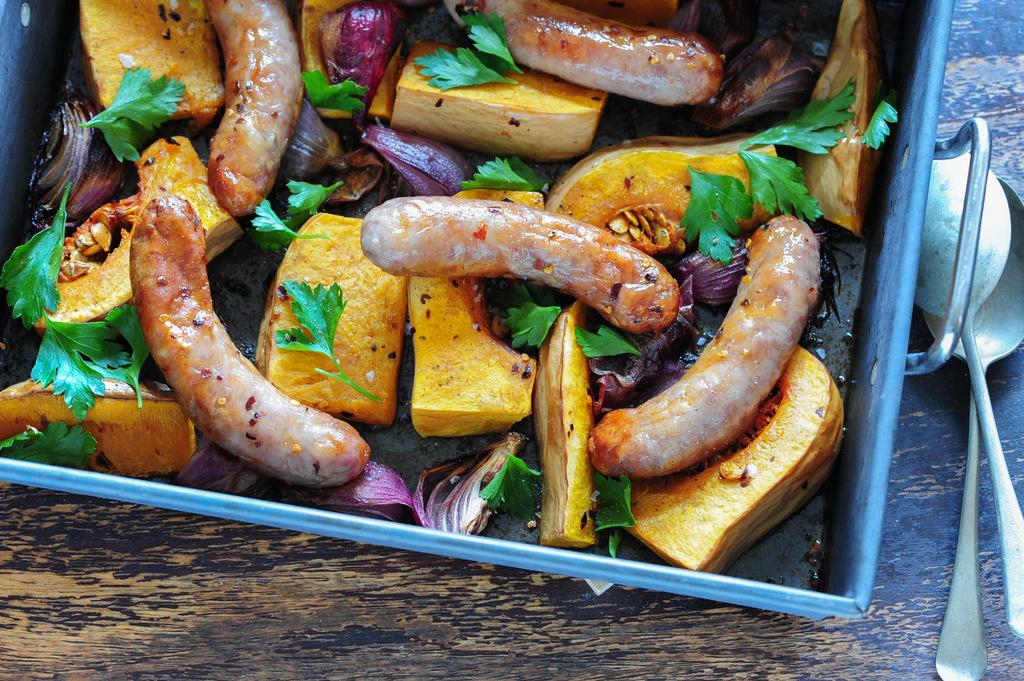What is placed on the wooden surface in the image? There is a tray on a wooden surface in the image. What can be found near the tray? There are spoons near the tray. What types of food are in the tray? In the tray, there are sausages, coriander leaves, and onion pieces. Are there any other items visible in the tray? Yes, there are other items visible in the tray. What type of calendar is visible on the tray? There is no calendar present on the tray or in the image. 